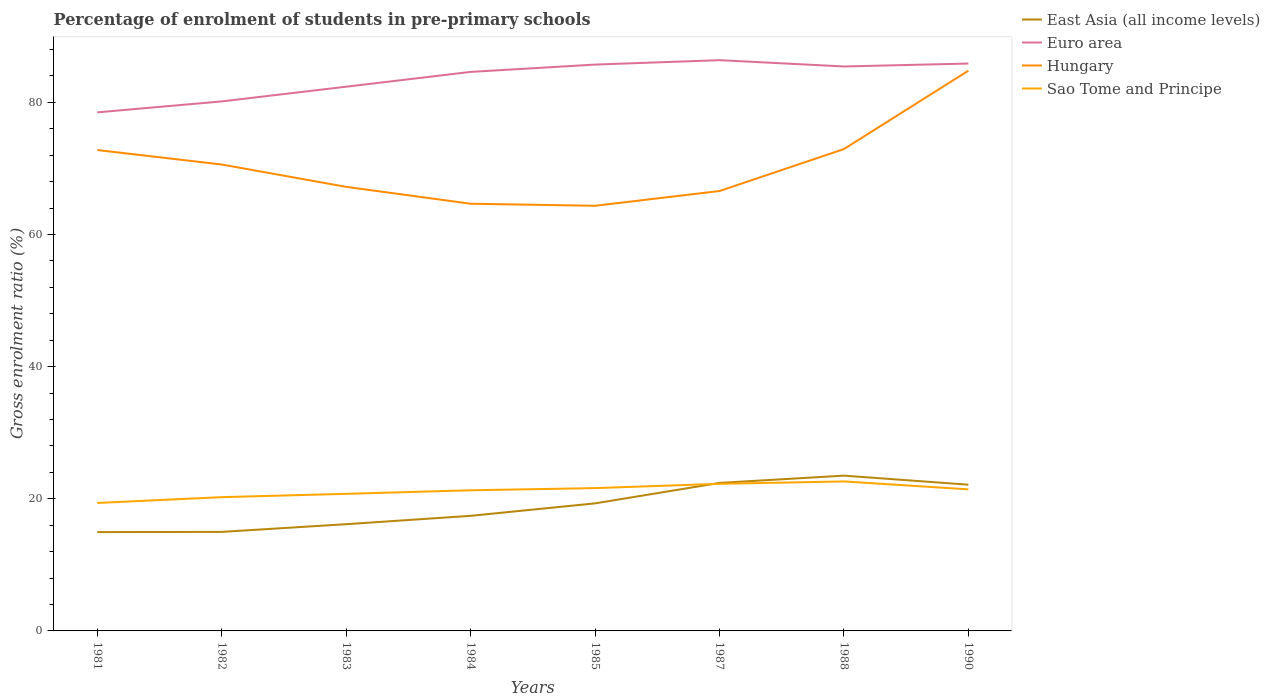Is the number of lines equal to the number of legend labels?
Provide a short and direct response. Yes. Across all years, what is the maximum percentage of students enrolled in pre-primary schools in Euro area?
Offer a terse response. 78.49. What is the total percentage of students enrolled in pre-primary schools in East Asia (all income levels) in the graph?
Offer a very short reply. -6.08. What is the difference between the highest and the second highest percentage of students enrolled in pre-primary schools in Hungary?
Your response must be concise. 20.45. What is the difference between the highest and the lowest percentage of students enrolled in pre-primary schools in Sao Tome and Principe?
Keep it short and to the point. 5. Is the percentage of students enrolled in pre-primary schools in Hungary strictly greater than the percentage of students enrolled in pre-primary schools in Euro area over the years?
Your response must be concise. Yes. How many lines are there?
Keep it short and to the point. 4. Are the values on the major ticks of Y-axis written in scientific E-notation?
Keep it short and to the point. No. Does the graph contain grids?
Your answer should be very brief. No. Where does the legend appear in the graph?
Ensure brevity in your answer.  Top right. How many legend labels are there?
Make the answer very short. 4. How are the legend labels stacked?
Your response must be concise. Vertical. What is the title of the graph?
Your response must be concise. Percentage of enrolment of students in pre-primary schools. Does "Belarus" appear as one of the legend labels in the graph?
Offer a terse response. No. What is the label or title of the Y-axis?
Ensure brevity in your answer.  Gross enrolment ratio (%). What is the Gross enrolment ratio (%) in East Asia (all income levels) in 1981?
Provide a short and direct response. 14.96. What is the Gross enrolment ratio (%) of Euro area in 1981?
Provide a short and direct response. 78.49. What is the Gross enrolment ratio (%) of Hungary in 1981?
Your response must be concise. 72.79. What is the Gross enrolment ratio (%) of Sao Tome and Principe in 1981?
Make the answer very short. 19.37. What is the Gross enrolment ratio (%) of East Asia (all income levels) in 1982?
Give a very brief answer. 14.99. What is the Gross enrolment ratio (%) in Euro area in 1982?
Your response must be concise. 80.15. What is the Gross enrolment ratio (%) of Hungary in 1982?
Offer a very short reply. 70.6. What is the Gross enrolment ratio (%) of Sao Tome and Principe in 1982?
Give a very brief answer. 20.25. What is the Gross enrolment ratio (%) of East Asia (all income levels) in 1983?
Keep it short and to the point. 16.15. What is the Gross enrolment ratio (%) in Euro area in 1983?
Ensure brevity in your answer.  82.37. What is the Gross enrolment ratio (%) of Hungary in 1983?
Ensure brevity in your answer.  67.21. What is the Gross enrolment ratio (%) of Sao Tome and Principe in 1983?
Ensure brevity in your answer.  20.75. What is the Gross enrolment ratio (%) of East Asia (all income levels) in 1984?
Your response must be concise. 17.42. What is the Gross enrolment ratio (%) of Euro area in 1984?
Provide a short and direct response. 84.61. What is the Gross enrolment ratio (%) of Hungary in 1984?
Offer a terse response. 64.66. What is the Gross enrolment ratio (%) of Sao Tome and Principe in 1984?
Give a very brief answer. 21.29. What is the Gross enrolment ratio (%) in East Asia (all income levels) in 1985?
Keep it short and to the point. 19.31. What is the Gross enrolment ratio (%) of Euro area in 1985?
Your answer should be compact. 85.72. What is the Gross enrolment ratio (%) of Hungary in 1985?
Provide a succinct answer. 64.35. What is the Gross enrolment ratio (%) in Sao Tome and Principe in 1985?
Ensure brevity in your answer.  21.62. What is the Gross enrolment ratio (%) of East Asia (all income levels) in 1987?
Keep it short and to the point. 22.4. What is the Gross enrolment ratio (%) in Euro area in 1987?
Provide a short and direct response. 86.39. What is the Gross enrolment ratio (%) in Hungary in 1987?
Your answer should be very brief. 66.58. What is the Gross enrolment ratio (%) in Sao Tome and Principe in 1987?
Offer a terse response. 22.27. What is the Gross enrolment ratio (%) in East Asia (all income levels) in 1988?
Your answer should be very brief. 23.5. What is the Gross enrolment ratio (%) in Euro area in 1988?
Offer a very short reply. 85.44. What is the Gross enrolment ratio (%) in Hungary in 1988?
Offer a terse response. 72.93. What is the Gross enrolment ratio (%) in Sao Tome and Principe in 1988?
Your response must be concise. 22.63. What is the Gross enrolment ratio (%) of East Asia (all income levels) in 1990?
Make the answer very short. 22.13. What is the Gross enrolment ratio (%) of Euro area in 1990?
Your answer should be compact. 85.88. What is the Gross enrolment ratio (%) in Hungary in 1990?
Your answer should be very brief. 84.8. What is the Gross enrolment ratio (%) in Sao Tome and Principe in 1990?
Your answer should be very brief. 21.43. Across all years, what is the maximum Gross enrolment ratio (%) of East Asia (all income levels)?
Make the answer very short. 23.5. Across all years, what is the maximum Gross enrolment ratio (%) of Euro area?
Ensure brevity in your answer.  86.39. Across all years, what is the maximum Gross enrolment ratio (%) in Hungary?
Your answer should be very brief. 84.8. Across all years, what is the maximum Gross enrolment ratio (%) in Sao Tome and Principe?
Make the answer very short. 22.63. Across all years, what is the minimum Gross enrolment ratio (%) of East Asia (all income levels)?
Make the answer very short. 14.96. Across all years, what is the minimum Gross enrolment ratio (%) in Euro area?
Offer a terse response. 78.49. Across all years, what is the minimum Gross enrolment ratio (%) in Hungary?
Your response must be concise. 64.35. Across all years, what is the minimum Gross enrolment ratio (%) in Sao Tome and Principe?
Ensure brevity in your answer.  19.37. What is the total Gross enrolment ratio (%) of East Asia (all income levels) in the graph?
Give a very brief answer. 150.87. What is the total Gross enrolment ratio (%) of Euro area in the graph?
Make the answer very short. 669.05. What is the total Gross enrolment ratio (%) in Hungary in the graph?
Your answer should be compact. 563.92. What is the total Gross enrolment ratio (%) in Sao Tome and Principe in the graph?
Your answer should be very brief. 169.59. What is the difference between the Gross enrolment ratio (%) of East Asia (all income levels) in 1981 and that in 1982?
Provide a short and direct response. -0.03. What is the difference between the Gross enrolment ratio (%) in Euro area in 1981 and that in 1982?
Give a very brief answer. -1.66. What is the difference between the Gross enrolment ratio (%) of Hungary in 1981 and that in 1982?
Provide a short and direct response. 2.19. What is the difference between the Gross enrolment ratio (%) of Sao Tome and Principe in 1981 and that in 1982?
Provide a succinct answer. -0.88. What is the difference between the Gross enrolment ratio (%) of East Asia (all income levels) in 1981 and that in 1983?
Keep it short and to the point. -1.19. What is the difference between the Gross enrolment ratio (%) of Euro area in 1981 and that in 1983?
Provide a succinct answer. -3.89. What is the difference between the Gross enrolment ratio (%) in Hungary in 1981 and that in 1983?
Offer a terse response. 5.57. What is the difference between the Gross enrolment ratio (%) of Sao Tome and Principe in 1981 and that in 1983?
Your response must be concise. -1.38. What is the difference between the Gross enrolment ratio (%) in East Asia (all income levels) in 1981 and that in 1984?
Your answer should be compact. -2.46. What is the difference between the Gross enrolment ratio (%) of Euro area in 1981 and that in 1984?
Provide a succinct answer. -6.12. What is the difference between the Gross enrolment ratio (%) in Hungary in 1981 and that in 1984?
Make the answer very short. 8.13. What is the difference between the Gross enrolment ratio (%) in Sao Tome and Principe in 1981 and that in 1984?
Give a very brief answer. -1.92. What is the difference between the Gross enrolment ratio (%) of East Asia (all income levels) in 1981 and that in 1985?
Provide a short and direct response. -4.35. What is the difference between the Gross enrolment ratio (%) in Euro area in 1981 and that in 1985?
Offer a very short reply. -7.23. What is the difference between the Gross enrolment ratio (%) in Hungary in 1981 and that in 1985?
Your answer should be very brief. 8.44. What is the difference between the Gross enrolment ratio (%) in Sao Tome and Principe in 1981 and that in 1985?
Your response must be concise. -2.25. What is the difference between the Gross enrolment ratio (%) in East Asia (all income levels) in 1981 and that in 1987?
Give a very brief answer. -7.44. What is the difference between the Gross enrolment ratio (%) in Euro area in 1981 and that in 1987?
Your answer should be very brief. -7.9. What is the difference between the Gross enrolment ratio (%) in Hungary in 1981 and that in 1987?
Offer a terse response. 6.21. What is the difference between the Gross enrolment ratio (%) of Sao Tome and Principe in 1981 and that in 1987?
Make the answer very short. -2.9. What is the difference between the Gross enrolment ratio (%) of East Asia (all income levels) in 1981 and that in 1988?
Offer a terse response. -8.55. What is the difference between the Gross enrolment ratio (%) of Euro area in 1981 and that in 1988?
Keep it short and to the point. -6.95. What is the difference between the Gross enrolment ratio (%) in Hungary in 1981 and that in 1988?
Keep it short and to the point. -0.14. What is the difference between the Gross enrolment ratio (%) of Sao Tome and Principe in 1981 and that in 1988?
Offer a terse response. -3.26. What is the difference between the Gross enrolment ratio (%) of East Asia (all income levels) in 1981 and that in 1990?
Make the answer very short. -7.17. What is the difference between the Gross enrolment ratio (%) in Euro area in 1981 and that in 1990?
Provide a short and direct response. -7.39. What is the difference between the Gross enrolment ratio (%) of Hungary in 1981 and that in 1990?
Your answer should be very brief. -12.01. What is the difference between the Gross enrolment ratio (%) of Sao Tome and Principe in 1981 and that in 1990?
Ensure brevity in your answer.  -2.06. What is the difference between the Gross enrolment ratio (%) of East Asia (all income levels) in 1982 and that in 1983?
Offer a terse response. -1.16. What is the difference between the Gross enrolment ratio (%) of Euro area in 1982 and that in 1983?
Provide a succinct answer. -2.23. What is the difference between the Gross enrolment ratio (%) in Hungary in 1982 and that in 1983?
Your response must be concise. 3.38. What is the difference between the Gross enrolment ratio (%) of Sao Tome and Principe in 1982 and that in 1983?
Your answer should be very brief. -0.5. What is the difference between the Gross enrolment ratio (%) of East Asia (all income levels) in 1982 and that in 1984?
Ensure brevity in your answer.  -2.43. What is the difference between the Gross enrolment ratio (%) in Euro area in 1982 and that in 1984?
Provide a succinct answer. -4.47. What is the difference between the Gross enrolment ratio (%) in Hungary in 1982 and that in 1984?
Your answer should be compact. 5.94. What is the difference between the Gross enrolment ratio (%) in Sao Tome and Principe in 1982 and that in 1984?
Your response must be concise. -1.04. What is the difference between the Gross enrolment ratio (%) in East Asia (all income levels) in 1982 and that in 1985?
Offer a terse response. -4.32. What is the difference between the Gross enrolment ratio (%) of Euro area in 1982 and that in 1985?
Offer a terse response. -5.58. What is the difference between the Gross enrolment ratio (%) in Hungary in 1982 and that in 1985?
Keep it short and to the point. 6.25. What is the difference between the Gross enrolment ratio (%) in Sao Tome and Principe in 1982 and that in 1985?
Your response must be concise. -1.37. What is the difference between the Gross enrolment ratio (%) in East Asia (all income levels) in 1982 and that in 1987?
Your answer should be compact. -7.41. What is the difference between the Gross enrolment ratio (%) of Euro area in 1982 and that in 1987?
Provide a succinct answer. -6.24. What is the difference between the Gross enrolment ratio (%) of Hungary in 1982 and that in 1987?
Provide a succinct answer. 4.01. What is the difference between the Gross enrolment ratio (%) in Sao Tome and Principe in 1982 and that in 1987?
Your answer should be compact. -2.02. What is the difference between the Gross enrolment ratio (%) in East Asia (all income levels) in 1982 and that in 1988?
Offer a very short reply. -8.51. What is the difference between the Gross enrolment ratio (%) in Euro area in 1982 and that in 1988?
Make the answer very short. -5.29. What is the difference between the Gross enrolment ratio (%) in Hungary in 1982 and that in 1988?
Offer a very short reply. -2.34. What is the difference between the Gross enrolment ratio (%) in Sao Tome and Principe in 1982 and that in 1988?
Ensure brevity in your answer.  -2.38. What is the difference between the Gross enrolment ratio (%) in East Asia (all income levels) in 1982 and that in 1990?
Your response must be concise. -7.14. What is the difference between the Gross enrolment ratio (%) in Euro area in 1982 and that in 1990?
Provide a short and direct response. -5.73. What is the difference between the Gross enrolment ratio (%) of Hungary in 1982 and that in 1990?
Make the answer very short. -14.2. What is the difference between the Gross enrolment ratio (%) in Sao Tome and Principe in 1982 and that in 1990?
Offer a very short reply. -1.18. What is the difference between the Gross enrolment ratio (%) in East Asia (all income levels) in 1983 and that in 1984?
Provide a short and direct response. -1.27. What is the difference between the Gross enrolment ratio (%) of Euro area in 1983 and that in 1984?
Give a very brief answer. -2.24. What is the difference between the Gross enrolment ratio (%) of Hungary in 1983 and that in 1984?
Provide a succinct answer. 2.55. What is the difference between the Gross enrolment ratio (%) in Sao Tome and Principe in 1983 and that in 1984?
Keep it short and to the point. -0.54. What is the difference between the Gross enrolment ratio (%) of East Asia (all income levels) in 1983 and that in 1985?
Provide a succinct answer. -3.15. What is the difference between the Gross enrolment ratio (%) of Euro area in 1983 and that in 1985?
Your answer should be very brief. -3.35. What is the difference between the Gross enrolment ratio (%) of Hungary in 1983 and that in 1985?
Offer a very short reply. 2.86. What is the difference between the Gross enrolment ratio (%) in Sao Tome and Principe in 1983 and that in 1985?
Ensure brevity in your answer.  -0.87. What is the difference between the Gross enrolment ratio (%) of East Asia (all income levels) in 1983 and that in 1987?
Give a very brief answer. -6.25. What is the difference between the Gross enrolment ratio (%) of Euro area in 1983 and that in 1987?
Offer a terse response. -4.02. What is the difference between the Gross enrolment ratio (%) in Hungary in 1983 and that in 1987?
Keep it short and to the point. 0.63. What is the difference between the Gross enrolment ratio (%) in Sao Tome and Principe in 1983 and that in 1987?
Provide a short and direct response. -1.52. What is the difference between the Gross enrolment ratio (%) of East Asia (all income levels) in 1983 and that in 1988?
Make the answer very short. -7.35. What is the difference between the Gross enrolment ratio (%) of Euro area in 1983 and that in 1988?
Your response must be concise. -3.06. What is the difference between the Gross enrolment ratio (%) of Hungary in 1983 and that in 1988?
Your response must be concise. -5.72. What is the difference between the Gross enrolment ratio (%) of Sao Tome and Principe in 1983 and that in 1988?
Give a very brief answer. -1.88. What is the difference between the Gross enrolment ratio (%) of East Asia (all income levels) in 1983 and that in 1990?
Your answer should be compact. -5.98. What is the difference between the Gross enrolment ratio (%) in Euro area in 1983 and that in 1990?
Give a very brief answer. -3.5. What is the difference between the Gross enrolment ratio (%) of Hungary in 1983 and that in 1990?
Your answer should be compact. -17.58. What is the difference between the Gross enrolment ratio (%) in Sao Tome and Principe in 1983 and that in 1990?
Your answer should be compact. -0.68. What is the difference between the Gross enrolment ratio (%) in East Asia (all income levels) in 1984 and that in 1985?
Ensure brevity in your answer.  -1.89. What is the difference between the Gross enrolment ratio (%) in Euro area in 1984 and that in 1985?
Your response must be concise. -1.11. What is the difference between the Gross enrolment ratio (%) of Hungary in 1984 and that in 1985?
Offer a terse response. 0.31. What is the difference between the Gross enrolment ratio (%) in Sao Tome and Principe in 1984 and that in 1985?
Make the answer very short. -0.33. What is the difference between the Gross enrolment ratio (%) in East Asia (all income levels) in 1984 and that in 1987?
Ensure brevity in your answer.  -4.98. What is the difference between the Gross enrolment ratio (%) in Euro area in 1984 and that in 1987?
Keep it short and to the point. -1.78. What is the difference between the Gross enrolment ratio (%) in Hungary in 1984 and that in 1987?
Your answer should be very brief. -1.92. What is the difference between the Gross enrolment ratio (%) of Sao Tome and Principe in 1984 and that in 1987?
Give a very brief answer. -0.98. What is the difference between the Gross enrolment ratio (%) in East Asia (all income levels) in 1984 and that in 1988?
Offer a very short reply. -6.08. What is the difference between the Gross enrolment ratio (%) in Euro area in 1984 and that in 1988?
Offer a terse response. -0.82. What is the difference between the Gross enrolment ratio (%) in Hungary in 1984 and that in 1988?
Offer a terse response. -8.27. What is the difference between the Gross enrolment ratio (%) of Sao Tome and Principe in 1984 and that in 1988?
Offer a very short reply. -1.34. What is the difference between the Gross enrolment ratio (%) of East Asia (all income levels) in 1984 and that in 1990?
Make the answer very short. -4.71. What is the difference between the Gross enrolment ratio (%) in Euro area in 1984 and that in 1990?
Make the answer very short. -1.27. What is the difference between the Gross enrolment ratio (%) of Hungary in 1984 and that in 1990?
Offer a very short reply. -20.14. What is the difference between the Gross enrolment ratio (%) of Sao Tome and Principe in 1984 and that in 1990?
Your response must be concise. -0.14. What is the difference between the Gross enrolment ratio (%) of East Asia (all income levels) in 1985 and that in 1987?
Make the answer very short. -3.1. What is the difference between the Gross enrolment ratio (%) in Euro area in 1985 and that in 1987?
Make the answer very short. -0.67. What is the difference between the Gross enrolment ratio (%) of Hungary in 1985 and that in 1987?
Keep it short and to the point. -2.23. What is the difference between the Gross enrolment ratio (%) of Sao Tome and Principe in 1985 and that in 1987?
Provide a short and direct response. -0.65. What is the difference between the Gross enrolment ratio (%) of East Asia (all income levels) in 1985 and that in 1988?
Provide a short and direct response. -4.2. What is the difference between the Gross enrolment ratio (%) of Euro area in 1985 and that in 1988?
Make the answer very short. 0.29. What is the difference between the Gross enrolment ratio (%) in Hungary in 1985 and that in 1988?
Your response must be concise. -8.58. What is the difference between the Gross enrolment ratio (%) of Sao Tome and Principe in 1985 and that in 1988?
Offer a terse response. -1.01. What is the difference between the Gross enrolment ratio (%) of East Asia (all income levels) in 1985 and that in 1990?
Offer a terse response. -2.83. What is the difference between the Gross enrolment ratio (%) of Euro area in 1985 and that in 1990?
Give a very brief answer. -0.16. What is the difference between the Gross enrolment ratio (%) in Hungary in 1985 and that in 1990?
Your answer should be very brief. -20.45. What is the difference between the Gross enrolment ratio (%) in Sao Tome and Principe in 1985 and that in 1990?
Keep it short and to the point. 0.19. What is the difference between the Gross enrolment ratio (%) in East Asia (all income levels) in 1987 and that in 1988?
Your answer should be very brief. -1.1. What is the difference between the Gross enrolment ratio (%) of Euro area in 1987 and that in 1988?
Give a very brief answer. 0.95. What is the difference between the Gross enrolment ratio (%) of Hungary in 1987 and that in 1988?
Your answer should be compact. -6.35. What is the difference between the Gross enrolment ratio (%) of Sao Tome and Principe in 1987 and that in 1988?
Your answer should be very brief. -0.36. What is the difference between the Gross enrolment ratio (%) of East Asia (all income levels) in 1987 and that in 1990?
Your answer should be compact. 0.27. What is the difference between the Gross enrolment ratio (%) of Euro area in 1987 and that in 1990?
Your response must be concise. 0.51. What is the difference between the Gross enrolment ratio (%) of Hungary in 1987 and that in 1990?
Provide a succinct answer. -18.22. What is the difference between the Gross enrolment ratio (%) in Sao Tome and Principe in 1987 and that in 1990?
Your response must be concise. 0.84. What is the difference between the Gross enrolment ratio (%) of East Asia (all income levels) in 1988 and that in 1990?
Make the answer very short. 1.37. What is the difference between the Gross enrolment ratio (%) of Euro area in 1988 and that in 1990?
Make the answer very short. -0.44. What is the difference between the Gross enrolment ratio (%) in Hungary in 1988 and that in 1990?
Make the answer very short. -11.87. What is the difference between the Gross enrolment ratio (%) of Sao Tome and Principe in 1988 and that in 1990?
Provide a short and direct response. 1.2. What is the difference between the Gross enrolment ratio (%) of East Asia (all income levels) in 1981 and the Gross enrolment ratio (%) of Euro area in 1982?
Provide a short and direct response. -65.19. What is the difference between the Gross enrolment ratio (%) in East Asia (all income levels) in 1981 and the Gross enrolment ratio (%) in Hungary in 1982?
Provide a succinct answer. -55.64. What is the difference between the Gross enrolment ratio (%) of East Asia (all income levels) in 1981 and the Gross enrolment ratio (%) of Sao Tome and Principe in 1982?
Provide a short and direct response. -5.29. What is the difference between the Gross enrolment ratio (%) of Euro area in 1981 and the Gross enrolment ratio (%) of Hungary in 1982?
Provide a short and direct response. 7.89. What is the difference between the Gross enrolment ratio (%) in Euro area in 1981 and the Gross enrolment ratio (%) in Sao Tome and Principe in 1982?
Give a very brief answer. 58.24. What is the difference between the Gross enrolment ratio (%) in Hungary in 1981 and the Gross enrolment ratio (%) in Sao Tome and Principe in 1982?
Your answer should be compact. 52.54. What is the difference between the Gross enrolment ratio (%) of East Asia (all income levels) in 1981 and the Gross enrolment ratio (%) of Euro area in 1983?
Keep it short and to the point. -67.42. What is the difference between the Gross enrolment ratio (%) of East Asia (all income levels) in 1981 and the Gross enrolment ratio (%) of Hungary in 1983?
Your answer should be compact. -52.26. What is the difference between the Gross enrolment ratio (%) in East Asia (all income levels) in 1981 and the Gross enrolment ratio (%) in Sao Tome and Principe in 1983?
Offer a very short reply. -5.79. What is the difference between the Gross enrolment ratio (%) of Euro area in 1981 and the Gross enrolment ratio (%) of Hungary in 1983?
Offer a very short reply. 11.27. What is the difference between the Gross enrolment ratio (%) in Euro area in 1981 and the Gross enrolment ratio (%) in Sao Tome and Principe in 1983?
Provide a short and direct response. 57.74. What is the difference between the Gross enrolment ratio (%) of Hungary in 1981 and the Gross enrolment ratio (%) of Sao Tome and Principe in 1983?
Provide a succinct answer. 52.04. What is the difference between the Gross enrolment ratio (%) of East Asia (all income levels) in 1981 and the Gross enrolment ratio (%) of Euro area in 1984?
Give a very brief answer. -69.65. What is the difference between the Gross enrolment ratio (%) of East Asia (all income levels) in 1981 and the Gross enrolment ratio (%) of Hungary in 1984?
Your response must be concise. -49.7. What is the difference between the Gross enrolment ratio (%) in East Asia (all income levels) in 1981 and the Gross enrolment ratio (%) in Sao Tome and Principe in 1984?
Offer a terse response. -6.33. What is the difference between the Gross enrolment ratio (%) of Euro area in 1981 and the Gross enrolment ratio (%) of Hungary in 1984?
Give a very brief answer. 13.83. What is the difference between the Gross enrolment ratio (%) of Euro area in 1981 and the Gross enrolment ratio (%) of Sao Tome and Principe in 1984?
Keep it short and to the point. 57.2. What is the difference between the Gross enrolment ratio (%) in Hungary in 1981 and the Gross enrolment ratio (%) in Sao Tome and Principe in 1984?
Offer a terse response. 51.5. What is the difference between the Gross enrolment ratio (%) in East Asia (all income levels) in 1981 and the Gross enrolment ratio (%) in Euro area in 1985?
Your answer should be very brief. -70.76. What is the difference between the Gross enrolment ratio (%) in East Asia (all income levels) in 1981 and the Gross enrolment ratio (%) in Hungary in 1985?
Provide a short and direct response. -49.39. What is the difference between the Gross enrolment ratio (%) in East Asia (all income levels) in 1981 and the Gross enrolment ratio (%) in Sao Tome and Principe in 1985?
Make the answer very short. -6.66. What is the difference between the Gross enrolment ratio (%) in Euro area in 1981 and the Gross enrolment ratio (%) in Hungary in 1985?
Your answer should be very brief. 14.14. What is the difference between the Gross enrolment ratio (%) of Euro area in 1981 and the Gross enrolment ratio (%) of Sao Tome and Principe in 1985?
Provide a succinct answer. 56.87. What is the difference between the Gross enrolment ratio (%) in Hungary in 1981 and the Gross enrolment ratio (%) in Sao Tome and Principe in 1985?
Make the answer very short. 51.17. What is the difference between the Gross enrolment ratio (%) of East Asia (all income levels) in 1981 and the Gross enrolment ratio (%) of Euro area in 1987?
Your answer should be very brief. -71.43. What is the difference between the Gross enrolment ratio (%) of East Asia (all income levels) in 1981 and the Gross enrolment ratio (%) of Hungary in 1987?
Provide a short and direct response. -51.62. What is the difference between the Gross enrolment ratio (%) of East Asia (all income levels) in 1981 and the Gross enrolment ratio (%) of Sao Tome and Principe in 1987?
Your answer should be very brief. -7.31. What is the difference between the Gross enrolment ratio (%) in Euro area in 1981 and the Gross enrolment ratio (%) in Hungary in 1987?
Keep it short and to the point. 11.91. What is the difference between the Gross enrolment ratio (%) of Euro area in 1981 and the Gross enrolment ratio (%) of Sao Tome and Principe in 1987?
Offer a terse response. 56.22. What is the difference between the Gross enrolment ratio (%) of Hungary in 1981 and the Gross enrolment ratio (%) of Sao Tome and Principe in 1987?
Your answer should be compact. 50.52. What is the difference between the Gross enrolment ratio (%) in East Asia (all income levels) in 1981 and the Gross enrolment ratio (%) in Euro area in 1988?
Make the answer very short. -70.48. What is the difference between the Gross enrolment ratio (%) of East Asia (all income levels) in 1981 and the Gross enrolment ratio (%) of Hungary in 1988?
Your answer should be compact. -57.97. What is the difference between the Gross enrolment ratio (%) of East Asia (all income levels) in 1981 and the Gross enrolment ratio (%) of Sao Tome and Principe in 1988?
Provide a short and direct response. -7.67. What is the difference between the Gross enrolment ratio (%) of Euro area in 1981 and the Gross enrolment ratio (%) of Hungary in 1988?
Your response must be concise. 5.56. What is the difference between the Gross enrolment ratio (%) of Euro area in 1981 and the Gross enrolment ratio (%) of Sao Tome and Principe in 1988?
Give a very brief answer. 55.86. What is the difference between the Gross enrolment ratio (%) in Hungary in 1981 and the Gross enrolment ratio (%) in Sao Tome and Principe in 1988?
Offer a terse response. 50.16. What is the difference between the Gross enrolment ratio (%) in East Asia (all income levels) in 1981 and the Gross enrolment ratio (%) in Euro area in 1990?
Ensure brevity in your answer.  -70.92. What is the difference between the Gross enrolment ratio (%) in East Asia (all income levels) in 1981 and the Gross enrolment ratio (%) in Hungary in 1990?
Provide a short and direct response. -69.84. What is the difference between the Gross enrolment ratio (%) in East Asia (all income levels) in 1981 and the Gross enrolment ratio (%) in Sao Tome and Principe in 1990?
Ensure brevity in your answer.  -6.47. What is the difference between the Gross enrolment ratio (%) of Euro area in 1981 and the Gross enrolment ratio (%) of Hungary in 1990?
Ensure brevity in your answer.  -6.31. What is the difference between the Gross enrolment ratio (%) in Euro area in 1981 and the Gross enrolment ratio (%) in Sao Tome and Principe in 1990?
Provide a succinct answer. 57.06. What is the difference between the Gross enrolment ratio (%) of Hungary in 1981 and the Gross enrolment ratio (%) of Sao Tome and Principe in 1990?
Your answer should be compact. 51.36. What is the difference between the Gross enrolment ratio (%) in East Asia (all income levels) in 1982 and the Gross enrolment ratio (%) in Euro area in 1983?
Keep it short and to the point. -67.38. What is the difference between the Gross enrolment ratio (%) in East Asia (all income levels) in 1982 and the Gross enrolment ratio (%) in Hungary in 1983?
Keep it short and to the point. -52.22. What is the difference between the Gross enrolment ratio (%) in East Asia (all income levels) in 1982 and the Gross enrolment ratio (%) in Sao Tome and Principe in 1983?
Your answer should be compact. -5.76. What is the difference between the Gross enrolment ratio (%) in Euro area in 1982 and the Gross enrolment ratio (%) in Hungary in 1983?
Provide a succinct answer. 12.93. What is the difference between the Gross enrolment ratio (%) in Euro area in 1982 and the Gross enrolment ratio (%) in Sao Tome and Principe in 1983?
Your answer should be very brief. 59.4. What is the difference between the Gross enrolment ratio (%) in Hungary in 1982 and the Gross enrolment ratio (%) in Sao Tome and Principe in 1983?
Offer a terse response. 49.85. What is the difference between the Gross enrolment ratio (%) of East Asia (all income levels) in 1982 and the Gross enrolment ratio (%) of Euro area in 1984?
Your answer should be very brief. -69.62. What is the difference between the Gross enrolment ratio (%) in East Asia (all income levels) in 1982 and the Gross enrolment ratio (%) in Hungary in 1984?
Offer a terse response. -49.67. What is the difference between the Gross enrolment ratio (%) of East Asia (all income levels) in 1982 and the Gross enrolment ratio (%) of Sao Tome and Principe in 1984?
Your response must be concise. -6.3. What is the difference between the Gross enrolment ratio (%) in Euro area in 1982 and the Gross enrolment ratio (%) in Hungary in 1984?
Provide a succinct answer. 15.49. What is the difference between the Gross enrolment ratio (%) of Euro area in 1982 and the Gross enrolment ratio (%) of Sao Tome and Principe in 1984?
Your response must be concise. 58.86. What is the difference between the Gross enrolment ratio (%) of Hungary in 1982 and the Gross enrolment ratio (%) of Sao Tome and Principe in 1984?
Your answer should be very brief. 49.31. What is the difference between the Gross enrolment ratio (%) in East Asia (all income levels) in 1982 and the Gross enrolment ratio (%) in Euro area in 1985?
Your answer should be very brief. -70.73. What is the difference between the Gross enrolment ratio (%) of East Asia (all income levels) in 1982 and the Gross enrolment ratio (%) of Hungary in 1985?
Provide a short and direct response. -49.36. What is the difference between the Gross enrolment ratio (%) in East Asia (all income levels) in 1982 and the Gross enrolment ratio (%) in Sao Tome and Principe in 1985?
Make the answer very short. -6.63. What is the difference between the Gross enrolment ratio (%) of Euro area in 1982 and the Gross enrolment ratio (%) of Hungary in 1985?
Offer a very short reply. 15.8. What is the difference between the Gross enrolment ratio (%) in Euro area in 1982 and the Gross enrolment ratio (%) in Sao Tome and Principe in 1985?
Ensure brevity in your answer.  58.53. What is the difference between the Gross enrolment ratio (%) in Hungary in 1982 and the Gross enrolment ratio (%) in Sao Tome and Principe in 1985?
Offer a terse response. 48.98. What is the difference between the Gross enrolment ratio (%) in East Asia (all income levels) in 1982 and the Gross enrolment ratio (%) in Euro area in 1987?
Your answer should be very brief. -71.4. What is the difference between the Gross enrolment ratio (%) in East Asia (all income levels) in 1982 and the Gross enrolment ratio (%) in Hungary in 1987?
Your response must be concise. -51.59. What is the difference between the Gross enrolment ratio (%) of East Asia (all income levels) in 1982 and the Gross enrolment ratio (%) of Sao Tome and Principe in 1987?
Your response must be concise. -7.28. What is the difference between the Gross enrolment ratio (%) of Euro area in 1982 and the Gross enrolment ratio (%) of Hungary in 1987?
Provide a succinct answer. 13.56. What is the difference between the Gross enrolment ratio (%) in Euro area in 1982 and the Gross enrolment ratio (%) in Sao Tome and Principe in 1987?
Provide a succinct answer. 57.88. What is the difference between the Gross enrolment ratio (%) of Hungary in 1982 and the Gross enrolment ratio (%) of Sao Tome and Principe in 1987?
Ensure brevity in your answer.  48.33. What is the difference between the Gross enrolment ratio (%) of East Asia (all income levels) in 1982 and the Gross enrolment ratio (%) of Euro area in 1988?
Make the answer very short. -70.45. What is the difference between the Gross enrolment ratio (%) in East Asia (all income levels) in 1982 and the Gross enrolment ratio (%) in Hungary in 1988?
Ensure brevity in your answer.  -57.94. What is the difference between the Gross enrolment ratio (%) of East Asia (all income levels) in 1982 and the Gross enrolment ratio (%) of Sao Tome and Principe in 1988?
Offer a terse response. -7.64. What is the difference between the Gross enrolment ratio (%) of Euro area in 1982 and the Gross enrolment ratio (%) of Hungary in 1988?
Your answer should be compact. 7.21. What is the difference between the Gross enrolment ratio (%) of Euro area in 1982 and the Gross enrolment ratio (%) of Sao Tome and Principe in 1988?
Offer a very short reply. 57.52. What is the difference between the Gross enrolment ratio (%) in Hungary in 1982 and the Gross enrolment ratio (%) in Sao Tome and Principe in 1988?
Offer a terse response. 47.97. What is the difference between the Gross enrolment ratio (%) of East Asia (all income levels) in 1982 and the Gross enrolment ratio (%) of Euro area in 1990?
Offer a terse response. -70.89. What is the difference between the Gross enrolment ratio (%) in East Asia (all income levels) in 1982 and the Gross enrolment ratio (%) in Hungary in 1990?
Your response must be concise. -69.81. What is the difference between the Gross enrolment ratio (%) of East Asia (all income levels) in 1982 and the Gross enrolment ratio (%) of Sao Tome and Principe in 1990?
Your answer should be compact. -6.44. What is the difference between the Gross enrolment ratio (%) in Euro area in 1982 and the Gross enrolment ratio (%) in Hungary in 1990?
Offer a terse response. -4.65. What is the difference between the Gross enrolment ratio (%) of Euro area in 1982 and the Gross enrolment ratio (%) of Sao Tome and Principe in 1990?
Offer a terse response. 58.72. What is the difference between the Gross enrolment ratio (%) of Hungary in 1982 and the Gross enrolment ratio (%) of Sao Tome and Principe in 1990?
Your answer should be compact. 49.17. What is the difference between the Gross enrolment ratio (%) of East Asia (all income levels) in 1983 and the Gross enrolment ratio (%) of Euro area in 1984?
Provide a succinct answer. -68.46. What is the difference between the Gross enrolment ratio (%) of East Asia (all income levels) in 1983 and the Gross enrolment ratio (%) of Hungary in 1984?
Your answer should be compact. -48.51. What is the difference between the Gross enrolment ratio (%) in East Asia (all income levels) in 1983 and the Gross enrolment ratio (%) in Sao Tome and Principe in 1984?
Your response must be concise. -5.13. What is the difference between the Gross enrolment ratio (%) of Euro area in 1983 and the Gross enrolment ratio (%) of Hungary in 1984?
Make the answer very short. 17.71. What is the difference between the Gross enrolment ratio (%) in Euro area in 1983 and the Gross enrolment ratio (%) in Sao Tome and Principe in 1984?
Provide a succinct answer. 61.09. What is the difference between the Gross enrolment ratio (%) in Hungary in 1983 and the Gross enrolment ratio (%) in Sao Tome and Principe in 1984?
Provide a succinct answer. 45.93. What is the difference between the Gross enrolment ratio (%) in East Asia (all income levels) in 1983 and the Gross enrolment ratio (%) in Euro area in 1985?
Make the answer very short. -69.57. What is the difference between the Gross enrolment ratio (%) in East Asia (all income levels) in 1983 and the Gross enrolment ratio (%) in Hungary in 1985?
Offer a terse response. -48.2. What is the difference between the Gross enrolment ratio (%) in East Asia (all income levels) in 1983 and the Gross enrolment ratio (%) in Sao Tome and Principe in 1985?
Offer a very short reply. -5.46. What is the difference between the Gross enrolment ratio (%) of Euro area in 1983 and the Gross enrolment ratio (%) of Hungary in 1985?
Keep it short and to the point. 18.02. What is the difference between the Gross enrolment ratio (%) of Euro area in 1983 and the Gross enrolment ratio (%) of Sao Tome and Principe in 1985?
Keep it short and to the point. 60.76. What is the difference between the Gross enrolment ratio (%) of Hungary in 1983 and the Gross enrolment ratio (%) of Sao Tome and Principe in 1985?
Give a very brief answer. 45.6. What is the difference between the Gross enrolment ratio (%) in East Asia (all income levels) in 1983 and the Gross enrolment ratio (%) in Euro area in 1987?
Offer a very short reply. -70.24. What is the difference between the Gross enrolment ratio (%) of East Asia (all income levels) in 1983 and the Gross enrolment ratio (%) of Hungary in 1987?
Keep it short and to the point. -50.43. What is the difference between the Gross enrolment ratio (%) in East Asia (all income levels) in 1983 and the Gross enrolment ratio (%) in Sao Tome and Principe in 1987?
Your response must be concise. -6.11. What is the difference between the Gross enrolment ratio (%) in Euro area in 1983 and the Gross enrolment ratio (%) in Hungary in 1987?
Ensure brevity in your answer.  15.79. What is the difference between the Gross enrolment ratio (%) in Euro area in 1983 and the Gross enrolment ratio (%) in Sao Tome and Principe in 1987?
Your answer should be compact. 60.11. What is the difference between the Gross enrolment ratio (%) of Hungary in 1983 and the Gross enrolment ratio (%) of Sao Tome and Principe in 1987?
Offer a terse response. 44.95. What is the difference between the Gross enrolment ratio (%) of East Asia (all income levels) in 1983 and the Gross enrolment ratio (%) of Euro area in 1988?
Make the answer very short. -69.28. What is the difference between the Gross enrolment ratio (%) in East Asia (all income levels) in 1983 and the Gross enrolment ratio (%) in Hungary in 1988?
Your answer should be very brief. -56.78. What is the difference between the Gross enrolment ratio (%) of East Asia (all income levels) in 1983 and the Gross enrolment ratio (%) of Sao Tome and Principe in 1988?
Provide a succinct answer. -6.47. What is the difference between the Gross enrolment ratio (%) in Euro area in 1983 and the Gross enrolment ratio (%) in Hungary in 1988?
Offer a very short reply. 9.44. What is the difference between the Gross enrolment ratio (%) in Euro area in 1983 and the Gross enrolment ratio (%) in Sao Tome and Principe in 1988?
Offer a terse response. 59.75. What is the difference between the Gross enrolment ratio (%) in Hungary in 1983 and the Gross enrolment ratio (%) in Sao Tome and Principe in 1988?
Your response must be concise. 44.59. What is the difference between the Gross enrolment ratio (%) in East Asia (all income levels) in 1983 and the Gross enrolment ratio (%) in Euro area in 1990?
Offer a very short reply. -69.73. What is the difference between the Gross enrolment ratio (%) in East Asia (all income levels) in 1983 and the Gross enrolment ratio (%) in Hungary in 1990?
Give a very brief answer. -68.65. What is the difference between the Gross enrolment ratio (%) of East Asia (all income levels) in 1983 and the Gross enrolment ratio (%) of Sao Tome and Principe in 1990?
Make the answer very short. -5.28. What is the difference between the Gross enrolment ratio (%) in Euro area in 1983 and the Gross enrolment ratio (%) in Hungary in 1990?
Keep it short and to the point. -2.42. What is the difference between the Gross enrolment ratio (%) of Euro area in 1983 and the Gross enrolment ratio (%) of Sao Tome and Principe in 1990?
Your response must be concise. 60.95. What is the difference between the Gross enrolment ratio (%) in Hungary in 1983 and the Gross enrolment ratio (%) in Sao Tome and Principe in 1990?
Offer a terse response. 45.78. What is the difference between the Gross enrolment ratio (%) in East Asia (all income levels) in 1984 and the Gross enrolment ratio (%) in Euro area in 1985?
Provide a short and direct response. -68.3. What is the difference between the Gross enrolment ratio (%) of East Asia (all income levels) in 1984 and the Gross enrolment ratio (%) of Hungary in 1985?
Keep it short and to the point. -46.93. What is the difference between the Gross enrolment ratio (%) of East Asia (all income levels) in 1984 and the Gross enrolment ratio (%) of Sao Tome and Principe in 1985?
Your answer should be compact. -4.2. What is the difference between the Gross enrolment ratio (%) of Euro area in 1984 and the Gross enrolment ratio (%) of Hungary in 1985?
Make the answer very short. 20.26. What is the difference between the Gross enrolment ratio (%) in Euro area in 1984 and the Gross enrolment ratio (%) in Sao Tome and Principe in 1985?
Give a very brief answer. 63. What is the difference between the Gross enrolment ratio (%) of Hungary in 1984 and the Gross enrolment ratio (%) of Sao Tome and Principe in 1985?
Your answer should be compact. 43.04. What is the difference between the Gross enrolment ratio (%) in East Asia (all income levels) in 1984 and the Gross enrolment ratio (%) in Euro area in 1987?
Give a very brief answer. -68.97. What is the difference between the Gross enrolment ratio (%) in East Asia (all income levels) in 1984 and the Gross enrolment ratio (%) in Hungary in 1987?
Give a very brief answer. -49.16. What is the difference between the Gross enrolment ratio (%) of East Asia (all income levels) in 1984 and the Gross enrolment ratio (%) of Sao Tome and Principe in 1987?
Offer a terse response. -4.85. What is the difference between the Gross enrolment ratio (%) in Euro area in 1984 and the Gross enrolment ratio (%) in Hungary in 1987?
Make the answer very short. 18.03. What is the difference between the Gross enrolment ratio (%) in Euro area in 1984 and the Gross enrolment ratio (%) in Sao Tome and Principe in 1987?
Keep it short and to the point. 62.35. What is the difference between the Gross enrolment ratio (%) of Hungary in 1984 and the Gross enrolment ratio (%) of Sao Tome and Principe in 1987?
Your response must be concise. 42.39. What is the difference between the Gross enrolment ratio (%) in East Asia (all income levels) in 1984 and the Gross enrolment ratio (%) in Euro area in 1988?
Your answer should be compact. -68.02. What is the difference between the Gross enrolment ratio (%) in East Asia (all income levels) in 1984 and the Gross enrolment ratio (%) in Hungary in 1988?
Offer a very short reply. -55.51. What is the difference between the Gross enrolment ratio (%) in East Asia (all income levels) in 1984 and the Gross enrolment ratio (%) in Sao Tome and Principe in 1988?
Give a very brief answer. -5.21. What is the difference between the Gross enrolment ratio (%) of Euro area in 1984 and the Gross enrolment ratio (%) of Hungary in 1988?
Ensure brevity in your answer.  11.68. What is the difference between the Gross enrolment ratio (%) in Euro area in 1984 and the Gross enrolment ratio (%) in Sao Tome and Principe in 1988?
Give a very brief answer. 61.99. What is the difference between the Gross enrolment ratio (%) in Hungary in 1984 and the Gross enrolment ratio (%) in Sao Tome and Principe in 1988?
Offer a very short reply. 42.03. What is the difference between the Gross enrolment ratio (%) in East Asia (all income levels) in 1984 and the Gross enrolment ratio (%) in Euro area in 1990?
Make the answer very short. -68.46. What is the difference between the Gross enrolment ratio (%) in East Asia (all income levels) in 1984 and the Gross enrolment ratio (%) in Hungary in 1990?
Your answer should be compact. -67.38. What is the difference between the Gross enrolment ratio (%) of East Asia (all income levels) in 1984 and the Gross enrolment ratio (%) of Sao Tome and Principe in 1990?
Make the answer very short. -4.01. What is the difference between the Gross enrolment ratio (%) of Euro area in 1984 and the Gross enrolment ratio (%) of Hungary in 1990?
Offer a terse response. -0.18. What is the difference between the Gross enrolment ratio (%) in Euro area in 1984 and the Gross enrolment ratio (%) in Sao Tome and Principe in 1990?
Your answer should be very brief. 63.18. What is the difference between the Gross enrolment ratio (%) of Hungary in 1984 and the Gross enrolment ratio (%) of Sao Tome and Principe in 1990?
Your response must be concise. 43.23. What is the difference between the Gross enrolment ratio (%) in East Asia (all income levels) in 1985 and the Gross enrolment ratio (%) in Euro area in 1987?
Offer a terse response. -67.08. What is the difference between the Gross enrolment ratio (%) in East Asia (all income levels) in 1985 and the Gross enrolment ratio (%) in Hungary in 1987?
Your response must be concise. -47.28. What is the difference between the Gross enrolment ratio (%) in East Asia (all income levels) in 1985 and the Gross enrolment ratio (%) in Sao Tome and Principe in 1987?
Ensure brevity in your answer.  -2.96. What is the difference between the Gross enrolment ratio (%) of Euro area in 1985 and the Gross enrolment ratio (%) of Hungary in 1987?
Your response must be concise. 19.14. What is the difference between the Gross enrolment ratio (%) in Euro area in 1985 and the Gross enrolment ratio (%) in Sao Tome and Principe in 1987?
Offer a very short reply. 63.46. What is the difference between the Gross enrolment ratio (%) in Hungary in 1985 and the Gross enrolment ratio (%) in Sao Tome and Principe in 1987?
Offer a terse response. 42.08. What is the difference between the Gross enrolment ratio (%) in East Asia (all income levels) in 1985 and the Gross enrolment ratio (%) in Euro area in 1988?
Ensure brevity in your answer.  -66.13. What is the difference between the Gross enrolment ratio (%) of East Asia (all income levels) in 1985 and the Gross enrolment ratio (%) of Hungary in 1988?
Make the answer very short. -53.63. What is the difference between the Gross enrolment ratio (%) of East Asia (all income levels) in 1985 and the Gross enrolment ratio (%) of Sao Tome and Principe in 1988?
Offer a very short reply. -3.32. What is the difference between the Gross enrolment ratio (%) of Euro area in 1985 and the Gross enrolment ratio (%) of Hungary in 1988?
Ensure brevity in your answer.  12.79. What is the difference between the Gross enrolment ratio (%) of Euro area in 1985 and the Gross enrolment ratio (%) of Sao Tome and Principe in 1988?
Give a very brief answer. 63.1. What is the difference between the Gross enrolment ratio (%) in Hungary in 1985 and the Gross enrolment ratio (%) in Sao Tome and Principe in 1988?
Provide a succinct answer. 41.72. What is the difference between the Gross enrolment ratio (%) in East Asia (all income levels) in 1985 and the Gross enrolment ratio (%) in Euro area in 1990?
Offer a very short reply. -66.57. What is the difference between the Gross enrolment ratio (%) of East Asia (all income levels) in 1985 and the Gross enrolment ratio (%) of Hungary in 1990?
Provide a short and direct response. -65.49. What is the difference between the Gross enrolment ratio (%) of East Asia (all income levels) in 1985 and the Gross enrolment ratio (%) of Sao Tome and Principe in 1990?
Your answer should be very brief. -2.12. What is the difference between the Gross enrolment ratio (%) in Euro area in 1985 and the Gross enrolment ratio (%) in Hungary in 1990?
Offer a terse response. 0.92. What is the difference between the Gross enrolment ratio (%) of Euro area in 1985 and the Gross enrolment ratio (%) of Sao Tome and Principe in 1990?
Keep it short and to the point. 64.29. What is the difference between the Gross enrolment ratio (%) in Hungary in 1985 and the Gross enrolment ratio (%) in Sao Tome and Principe in 1990?
Make the answer very short. 42.92. What is the difference between the Gross enrolment ratio (%) in East Asia (all income levels) in 1987 and the Gross enrolment ratio (%) in Euro area in 1988?
Your answer should be compact. -63.03. What is the difference between the Gross enrolment ratio (%) in East Asia (all income levels) in 1987 and the Gross enrolment ratio (%) in Hungary in 1988?
Give a very brief answer. -50.53. What is the difference between the Gross enrolment ratio (%) of East Asia (all income levels) in 1987 and the Gross enrolment ratio (%) of Sao Tome and Principe in 1988?
Keep it short and to the point. -0.22. What is the difference between the Gross enrolment ratio (%) of Euro area in 1987 and the Gross enrolment ratio (%) of Hungary in 1988?
Offer a terse response. 13.46. What is the difference between the Gross enrolment ratio (%) in Euro area in 1987 and the Gross enrolment ratio (%) in Sao Tome and Principe in 1988?
Provide a short and direct response. 63.76. What is the difference between the Gross enrolment ratio (%) in Hungary in 1987 and the Gross enrolment ratio (%) in Sao Tome and Principe in 1988?
Give a very brief answer. 43.96. What is the difference between the Gross enrolment ratio (%) of East Asia (all income levels) in 1987 and the Gross enrolment ratio (%) of Euro area in 1990?
Keep it short and to the point. -63.48. What is the difference between the Gross enrolment ratio (%) of East Asia (all income levels) in 1987 and the Gross enrolment ratio (%) of Hungary in 1990?
Provide a short and direct response. -62.4. What is the difference between the Gross enrolment ratio (%) in East Asia (all income levels) in 1987 and the Gross enrolment ratio (%) in Sao Tome and Principe in 1990?
Make the answer very short. 0.97. What is the difference between the Gross enrolment ratio (%) in Euro area in 1987 and the Gross enrolment ratio (%) in Hungary in 1990?
Your answer should be compact. 1.59. What is the difference between the Gross enrolment ratio (%) in Euro area in 1987 and the Gross enrolment ratio (%) in Sao Tome and Principe in 1990?
Offer a very short reply. 64.96. What is the difference between the Gross enrolment ratio (%) in Hungary in 1987 and the Gross enrolment ratio (%) in Sao Tome and Principe in 1990?
Make the answer very short. 45.15. What is the difference between the Gross enrolment ratio (%) of East Asia (all income levels) in 1988 and the Gross enrolment ratio (%) of Euro area in 1990?
Your response must be concise. -62.37. What is the difference between the Gross enrolment ratio (%) in East Asia (all income levels) in 1988 and the Gross enrolment ratio (%) in Hungary in 1990?
Your answer should be very brief. -61.29. What is the difference between the Gross enrolment ratio (%) in East Asia (all income levels) in 1988 and the Gross enrolment ratio (%) in Sao Tome and Principe in 1990?
Offer a terse response. 2.08. What is the difference between the Gross enrolment ratio (%) in Euro area in 1988 and the Gross enrolment ratio (%) in Hungary in 1990?
Offer a very short reply. 0.64. What is the difference between the Gross enrolment ratio (%) of Euro area in 1988 and the Gross enrolment ratio (%) of Sao Tome and Principe in 1990?
Ensure brevity in your answer.  64.01. What is the difference between the Gross enrolment ratio (%) in Hungary in 1988 and the Gross enrolment ratio (%) in Sao Tome and Principe in 1990?
Your answer should be compact. 51.5. What is the average Gross enrolment ratio (%) of East Asia (all income levels) per year?
Keep it short and to the point. 18.86. What is the average Gross enrolment ratio (%) of Euro area per year?
Give a very brief answer. 83.63. What is the average Gross enrolment ratio (%) of Hungary per year?
Give a very brief answer. 70.49. What is the average Gross enrolment ratio (%) of Sao Tome and Principe per year?
Your answer should be very brief. 21.2. In the year 1981, what is the difference between the Gross enrolment ratio (%) in East Asia (all income levels) and Gross enrolment ratio (%) in Euro area?
Give a very brief answer. -63.53. In the year 1981, what is the difference between the Gross enrolment ratio (%) of East Asia (all income levels) and Gross enrolment ratio (%) of Hungary?
Offer a terse response. -57.83. In the year 1981, what is the difference between the Gross enrolment ratio (%) of East Asia (all income levels) and Gross enrolment ratio (%) of Sao Tome and Principe?
Provide a short and direct response. -4.41. In the year 1981, what is the difference between the Gross enrolment ratio (%) in Euro area and Gross enrolment ratio (%) in Hungary?
Ensure brevity in your answer.  5.7. In the year 1981, what is the difference between the Gross enrolment ratio (%) of Euro area and Gross enrolment ratio (%) of Sao Tome and Principe?
Provide a short and direct response. 59.12. In the year 1981, what is the difference between the Gross enrolment ratio (%) of Hungary and Gross enrolment ratio (%) of Sao Tome and Principe?
Provide a succinct answer. 53.42. In the year 1982, what is the difference between the Gross enrolment ratio (%) of East Asia (all income levels) and Gross enrolment ratio (%) of Euro area?
Make the answer very short. -65.16. In the year 1982, what is the difference between the Gross enrolment ratio (%) in East Asia (all income levels) and Gross enrolment ratio (%) in Hungary?
Make the answer very short. -55.61. In the year 1982, what is the difference between the Gross enrolment ratio (%) of East Asia (all income levels) and Gross enrolment ratio (%) of Sao Tome and Principe?
Your answer should be compact. -5.26. In the year 1982, what is the difference between the Gross enrolment ratio (%) in Euro area and Gross enrolment ratio (%) in Hungary?
Keep it short and to the point. 9.55. In the year 1982, what is the difference between the Gross enrolment ratio (%) of Euro area and Gross enrolment ratio (%) of Sao Tome and Principe?
Offer a very short reply. 59.9. In the year 1982, what is the difference between the Gross enrolment ratio (%) of Hungary and Gross enrolment ratio (%) of Sao Tome and Principe?
Offer a terse response. 50.35. In the year 1983, what is the difference between the Gross enrolment ratio (%) of East Asia (all income levels) and Gross enrolment ratio (%) of Euro area?
Make the answer very short. -66.22. In the year 1983, what is the difference between the Gross enrolment ratio (%) in East Asia (all income levels) and Gross enrolment ratio (%) in Hungary?
Offer a very short reply. -51.06. In the year 1983, what is the difference between the Gross enrolment ratio (%) in East Asia (all income levels) and Gross enrolment ratio (%) in Sao Tome and Principe?
Offer a very short reply. -4.6. In the year 1983, what is the difference between the Gross enrolment ratio (%) in Euro area and Gross enrolment ratio (%) in Hungary?
Ensure brevity in your answer.  15.16. In the year 1983, what is the difference between the Gross enrolment ratio (%) in Euro area and Gross enrolment ratio (%) in Sao Tome and Principe?
Give a very brief answer. 61.62. In the year 1983, what is the difference between the Gross enrolment ratio (%) of Hungary and Gross enrolment ratio (%) of Sao Tome and Principe?
Give a very brief answer. 46.46. In the year 1984, what is the difference between the Gross enrolment ratio (%) in East Asia (all income levels) and Gross enrolment ratio (%) in Euro area?
Give a very brief answer. -67.19. In the year 1984, what is the difference between the Gross enrolment ratio (%) of East Asia (all income levels) and Gross enrolment ratio (%) of Hungary?
Keep it short and to the point. -47.24. In the year 1984, what is the difference between the Gross enrolment ratio (%) in East Asia (all income levels) and Gross enrolment ratio (%) in Sao Tome and Principe?
Make the answer very short. -3.87. In the year 1984, what is the difference between the Gross enrolment ratio (%) in Euro area and Gross enrolment ratio (%) in Hungary?
Provide a succinct answer. 19.95. In the year 1984, what is the difference between the Gross enrolment ratio (%) in Euro area and Gross enrolment ratio (%) in Sao Tome and Principe?
Your answer should be very brief. 63.33. In the year 1984, what is the difference between the Gross enrolment ratio (%) in Hungary and Gross enrolment ratio (%) in Sao Tome and Principe?
Your response must be concise. 43.37. In the year 1985, what is the difference between the Gross enrolment ratio (%) of East Asia (all income levels) and Gross enrolment ratio (%) of Euro area?
Provide a short and direct response. -66.42. In the year 1985, what is the difference between the Gross enrolment ratio (%) of East Asia (all income levels) and Gross enrolment ratio (%) of Hungary?
Ensure brevity in your answer.  -45.04. In the year 1985, what is the difference between the Gross enrolment ratio (%) of East Asia (all income levels) and Gross enrolment ratio (%) of Sao Tome and Principe?
Make the answer very short. -2.31. In the year 1985, what is the difference between the Gross enrolment ratio (%) of Euro area and Gross enrolment ratio (%) of Hungary?
Your answer should be very brief. 21.37. In the year 1985, what is the difference between the Gross enrolment ratio (%) of Euro area and Gross enrolment ratio (%) of Sao Tome and Principe?
Your response must be concise. 64.11. In the year 1985, what is the difference between the Gross enrolment ratio (%) of Hungary and Gross enrolment ratio (%) of Sao Tome and Principe?
Make the answer very short. 42.73. In the year 1987, what is the difference between the Gross enrolment ratio (%) of East Asia (all income levels) and Gross enrolment ratio (%) of Euro area?
Provide a succinct answer. -63.99. In the year 1987, what is the difference between the Gross enrolment ratio (%) of East Asia (all income levels) and Gross enrolment ratio (%) of Hungary?
Ensure brevity in your answer.  -44.18. In the year 1987, what is the difference between the Gross enrolment ratio (%) in East Asia (all income levels) and Gross enrolment ratio (%) in Sao Tome and Principe?
Offer a very short reply. 0.14. In the year 1987, what is the difference between the Gross enrolment ratio (%) of Euro area and Gross enrolment ratio (%) of Hungary?
Provide a short and direct response. 19.81. In the year 1987, what is the difference between the Gross enrolment ratio (%) in Euro area and Gross enrolment ratio (%) in Sao Tome and Principe?
Your response must be concise. 64.12. In the year 1987, what is the difference between the Gross enrolment ratio (%) of Hungary and Gross enrolment ratio (%) of Sao Tome and Principe?
Ensure brevity in your answer.  44.32. In the year 1988, what is the difference between the Gross enrolment ratio (%) of East Asia (all income levels) and Gross enrolment ratio (%) of Euro area?
Keep it short and to the point. -61.93. In the year 1988, what is the difference between the Gross enrolment ratio (%) of East Asia (all income levels) and Gross enrolment ratio (%) of Hungary?
Ensure brevity in your answer.  -49.43. In the year 1988, what is the difference between the Gross enrolment ratio (%) of East Asia (all income levels) and Gross enrolment ratio (%) of Sao Tome and Principe?
Give a very brief answer. 0.88. In the year 1988, what is the difference between the Gross enrolment ratio (%) of Euro area and Gross enrolment ratio (%) of Hungary?
Give a very brief answer. 12.5. In the year 1988, what is the difference between the Gross enrolment ratio (%) of Euro area and Gross enrolment ratio (%) of Sao Tome and Principe?
Provide a short and direct response. 62.81. In the year 1988, what is the difference between the Gross enrolment ratio (%) of Hungary and Gross enrolment ratio (%) of Sao Tome and Principe?
Provide a succinct answer. 50.31. In the year 1990, what is the difference between the Gross enrolment ratio (%) of East Asia (all income levels) and Gross enrolment ratio (%) of Euro area?
Keep it short and to the point. -63.75. In the year 1990, what is the difference between the Gross enrolment ratio (%) in East Asia (all income levels) and Gross enrolment ratio (%) in Hungary?
Your answer should be very brief. -62.67. In the year 1990, what is the difference between the Gross enrolment ratio (%) of East Asia (all income levels) and Gross enrolment ratio (%) of Sao Tome and Principe?
Provide a short and direct response. 0.7. In the year 1990, what is the difference between the Gross enrolment ratio (%) in Euro area and Gross enrolment ratio (%) in Hungary?
Ensure brevity in your answer.  1.08. In the year 1990, what is the difference between the Gross enrolment ratio (%) in Euro area and Gross enrolment ratio (%) in Sao Tome and Principe?
Provide a succinct answer. 64.45. In the year 1990, what is the difference between the Gross enrolment ratio (%) of Hungary and Gross enrolment ratio (%) of Sao Tome and Principe?
Your answer should be compact. 63.37. What is the ratio of the Gross enrolment ratio (%) of East Asia (all income levels) in 1981 to that in 1982?
Provide a short and direct response. 1. What is the ratio of the Gross enrolment ratio (%) of Euro area in 1981 to that in 1982?
Ensure brevity in your answer.  0.98. What is the ratio of the Gross enrolment ratio (%) in Hungary in 1981 to that in 1982?
Make the answer very short. 1.03. What is the ratio of the Gross enrolment ratio (%) in Sao Tome and Principe in 1981 to that in 1982?
Offer a terse response. 0.96. What is the ratio of the Gross enrolment ratio (%) of East Asia (all income levels) in 1981 to that in 1983?
Give a very brief answer. 0.93. What is the ratio of the Gross enrolment ratio (%) in Euro area in 1981 to that in 1983?
Provide a succinct answer. 0.95. What is the ratio of the Gross enrolment ratio (%) in Hungary in 1981 to that in 1983?
Give a very brief answer. 1.08. What is the ratio of the Gross enrolment ratio (%) of Sao Tome and Principe in 1981 to that in 1983?
Provide a short and direct response. 0.93. What is the ratio of the Gross enrolment ratio (%) of East Asia (all income levels) in 1981 to that in 1984?
Give a very brief answer. 0.86. What is the ratio of the Gross enrolment ratio (%) of Euro area in 1981 to that in 1984?
Offer a very short reply. 0.93. What is the ratio of the Gross enrolment ratio (%) in Hungary in 1981 to that in 1984?
Give a very brief answer. 1.13. What is the ratio of the Gross enrolment ratio (%) in Sao Tome and Principe in 1981 to that in 1984?
Give a very brief answer. 0.91. What is the ratio of the Gross enrolment ratio (%) in East Asia (all income levels) in 1981 to that in 1985?
Offer a very short reply. 0.77. What is the ratio of the Gross enrolment ratio (%) of Euro area in 1981 to that in 1985?
Offer a terse response. 0.92. What is the ratio of the Gross enrolment ratio (%) in Hungary in 1981 to that in 1985?
Your answer should be very brief. 1.13. What is the ratio of the Gross enrolment ratio (%) of Sao Tome and Principe in 1981 to that in 1985?
Your response must be concise. 0.9. What is the ratio of the Gross enrolment ratio (%) in East Asia (all income levels) in 1981 to that in 1987?
Provide a short and direct response. 0.67. What is the ratio of the Gross enrolment ratio (%) of Euro area in 1981 to that in 1987?
Provide a short and direct response. 0.91. What is the ratio of the Gross enrolment ratio (%) of Hungary in 1981 to that in 1987?
Provide a succinct answer. 1.09. What is the ratio of the Gross enrolment ratio (%) in Sao Tome and Principe in 1981 to that in 1987?
Your answer should be compact. 0.87. What is the ratio of the Gross enrolment ratio (%) of East Asia (all income levels) in 1981 to that in 1988?
Keep it short and to the point. 0.64. What is the ratio of the Gross enrolment ratio (%) of Euro area in 1981 to that in 1988?
Offer a terse response. 0.92. What is the ratio of the Gross enrolment ratio (%) in Hungary in 1981 to that in 1988?
Provide a succinct answer. 1. What is the ratio of the Gross enrolment ratio (%) in Sao Tome and Principe in 1981 to that in 1988?
Offer a terse response. 0.86. What is the ratio of the Gross enrolment ratio (%) of East Asia (all income levels) in 1981 to that in 1990?
Provide a succinct answer. 0.68. What is the ratio of the Gross enrolment ratio (%) in Euro area in 1981 to that in 1990?
Provide a succinct answer. 0.91. What is the ratio of the Gross enrolment ratio (%) of Hungary in 1981 to that in 1990?
Your response must be concise. 0.86. What is the ratio of the Gross enrolment ratio (%) of Sao Tome and Principe in 1981 to that in 1990?
Provide a succinct answer. 0.9. What is the ratio of the Gross enrolment ratio (%) of East Asia (all income levels) in 1982 to that in 1983?
Give a very brief answer. 0.93. What is the ratio of the Gross enrolment ratio (%) in Euro area in 1982 to that in 1983?
Provide a succinct answer. 0.97. What is the ratio of the Gross enrolment ratio (%) in Hungary in 1982 to that in 1983?
Offer a very short reply. 1.05. What is the ratio of the Gross enrolment ratio (%) of Sao Tome and Principe in 1982 to that in 1983?
Provide a short and direct response. 0.98. What is the ratio of the Gross enrolment ratio (%) in East Asia (all income levels) in 1982 to that in 1984?
Offer a terse response. 0.86. What is the ratio of the Gross enrolment ratio (%) in Euro area in 1982 to that in 1984?
Your answer should be compact. 0.95. What is the ratio of the Gross enrolment ratio (%) in Hungary in 1982 to that in 1984?
Keep it short and to the point. 1.09. What is the ratio of the Gross enrolment ratio (%) in Sao Tome and Principe in 1982 to that in 1984?
Your answer should be very brief. 0.95. What is the ratio of the Gross enrolment ratio (%) in East Asia (all income levels) in 1982 to that in 1985?
Make the answer very short. 0.78. What is the ratio of the Gross enrolment ratio (%) of Euro area in 1982 to that in 1985?
Your answer should be compact. 0.94. What is the ratio of the Gross enrolment ratio (%) of Hungary in 1982 to that in 1985?
Provide a succinct answer. 1.1. What is the ratio of the Gross enrolment ratio (%) in Sao Tome and Principe in 1982 to that in 1985?
Ensure brevity in your answer.  0.94. What is the ratio of the Gross enrolment ratio (%) in East Asia (all income levels) in 1982 to that in 1987?
Provide a succinct answer. 0.67. What is the ratio of the Gross enrolment ratio (%) of Euro area in 1982 to that in 1987?
Your answer should be very brief. 0.93. What is the ratio of the Gross enrolment ratio (%) in Hungary in 1982 to that in 1987?
Provide a succinct answer. 1.06. What is the ratio of the Gross enrolment ratio (%) in Sao Tome and Principe in 1982 to that in 1987?
Provide a succinct answer. 0.91. What is the ratio of the Gross enrolment ratio (%) in East Asia (all income levels) in 1982 to that in 1988?
Keep it short and to the point. 0.64. What is the ratio of the Gross enrolment ratio (%) of Euro area in 1982 to that in 1988?
Ensure brevity in your answer.  0.94. What is the ratio of the Gross enrolment ratio (%) of Hungary in 1982 to that in 1988?
Provide a succinct answer. 0.97. What is the ratio of the Gross enrolment ratio (%) of Sao Tome and Principe in 1982 to that in 1988?
Offer a very short reply. 0.89. What is the ratio of the Gross enrolment ratio (%) in East Asia (all income levels) in 1982 to that in 1990?
Offer a terse response. 0.68. What is the ratio of the Gross enrolment ratio (%) in Hungary in 1982 to that in 1990?
Ensure brevity in your answer.  0.83. What is the ratio of the Gross enrolment ratio (%) of Sao Tome and Principe in 1982 to that in 1990?
Your response must be concise. 0.94. What is the ratio of the Gross enrolment ratio (%) of East Asia (all income levels) in 1983 to that in 1984?
Give a very brief answer. 0.93. What is the ratio of the Gross enrolment ratio (%) of Euro area in 1983 to that in 1984?
Provide a succinct answer. 0.97. What is the ratio of the Gross enrolment ratio (%) of Hungary in 1983 to that in 1984?
Provide a short and direct response. 1.04. What is the ratio of the Gross enrolment ratio (%) of Sao Tome and Principe in 1983 to that in 1984?
Your answer should be compact. 0.97. What is the ratio of the Gross enrolment ratio (%) in East Asia (all income levels) in 1983 to that in 1985?
Ensure brevity in your answer.  0.84. What is the ratio of the Gross enrolment ratio (%) in Euro area in 1983 to that in 1985?
Provide a succinct answer. 0.96. What is the ratio of the Gross enrolment ratio (%) in Hungary in 1983 to that in 1985?
Your answer should be compact. 1.04. What is the ratio of the Gross enrolment ratio (%) in Sao Tome and Principe in 1983 to that in 1985?
Make the answer very short. 0.96. What is the ratio of the Gross enrolment ratio (%) of East Asia (all income levels) in 1983 to that in 1987?
Your answer should be very brief. 0.72. What is the ratio of the Gross enrolment ratio (%) of Euro area in 1983 to that in 1987?
Provide a succinct answer. 0.95. What is the ratio of the Gross enrolment ratio (%) in Hungary in 1983 to that in 1987?
Provide a succinct answer. 1.01. What is the ratio of the Gross enrolment ratio (%) in Sao Tome and Principe in 1983 to that in 1987?
Provide a succinct answer. 0.93. What is the ratio of the Gross enrolment ratio (%) in East Asia (all income levels) in 1983 to that in 1988?
Offer a terse response. 0.69. What is the ratio of the Gross enrolment ratio (%) in Euro area in 1983 to that in 1988?
Provide a succinct answer. 0.96. What is the ratio of the Gross enrolment ratio (%) of Hungary in 1983 to that in 1988?
Keep it short and to the point. 0.92. What is the ratio of the Gross enrolment ratio (%) of Sao Tome and Principe in 1983 to that in 1988?
Ensure brevity in your answer.  0.92. What is the ratio of the Gross enrolment ratio (%) of East Asia (all income levels) in 1983 to that in 1990?
Your answer should be very brief. 0.73. What is the ratio of the Gross enrolment ratio (%) in Euro area in 1983 to that in 1990?
Your answer should be compact. 0.96. What is the ratio of the Gross enrolment ratio (%) in Hungary in 1983 to that in 1990?
Make the answer very short. 0.79. What is the ratio of the Gross enrolment ratio (%) of Sao Tome and Principe in 1983 to that in 1990?
Provide a succinct answer. 0.97. What is the ratio of the Gross enrolment ratio (%) of East Asia (all income levels) in 1984 to that in 1985?
Provide a short and direct response. 0.9. What is the ratio of the Gross enrolment ratio (%) in Euro area in 1984 to that in 1985?
Give a very brief answer. 0.99. What is the ratio of the Gross enrolment ratio (%) of Hungary in 1984 to that in 1985?
Your response must be concise. 1. What is the ratio of the Gross enrolment ratio (%) of East Asia (all income levels) in 1984 to that in 1987?
Offer a very short reply. 0.78. What is the ratio of the Gross enrolment ratio (%) in Euro area in 1984 to that in 1987?
Provide a succinct answer. 0.98. What is the ratio of the Gross enrolment ratio (%) in Hungary in 1984 to that in 1987?
Offer a very short reply. 0.97. What is the ratio of the Gross enrolment ratio (%) in Sao Tome and Principe in 1984 to that in 1987?
Offer a very short reply. 0.96. What is the ratio of the Gross enrolment ratio (%) of East Asia (all income levels) in 1984 to that in 1988?
Offer a very short reply. 0.74. What is the ratio of the Gross enrolment ratio (%) of Hungary in 1984 to that in 1988?
Ensure brevity in your answer.  0.89. What is the ratio of the Gross enrolment ratio (%) of Sao Tome and Principe in 1984 to that in 1988?
Your response must be concise. 0.94. What is the ratio of the Gross enrolment ratio (%) of East Asia (all income levels) in 1984 to that in 1990?
Make the answer very short. 0.79. What is the ratio of the Gross enrolment ratio (%) in Euro area in 1984 to that in 1990?
Your response must be concise. 0.99. What is the ratio of the Gross enrolment ratio (%) of Hungary in 1984 to that in 1990?
Offer a terse response. 0.76. What is the ratio of the Gross enrolment ratio (%) in Sao Tome and Principe in 1984 to that in 1990?
Your response must be concise. 0.99. What is the ratio of the Gross enrolment ratio (%) in East Asia (all income levels) in 1985 to that in 1987?
Your answer should be compact. 0.86. What is the ratio of the Gross enrolment ratio (%) in Hungary in 1985 to that in 1987?
Your answer should be very brief. 0.97. What is the ratio of the Gross enrolment ratio (%) of Sao Tome and Principe in 1985 to that in 1987?
Provide a short and direct response. 0.97. What is the ratio of the Gross enrolment ratio (%) in East Asia (all income levels) in 1985 to that in 1988?
Make the answer very short. 0.82. What is the ratio of the Gross enrolment ratio (%) in Euro area in 1985 to that in 1988?
Provide a short and direct response. 1. What is the ratio of the Gross enrolment ratio (%) of Hungary in 1985 to that in 1988?
Your answer should be very brief. 0.88. What is the ratio of the Gross enrolment ratio (%) in Sao Tome and Principe in 1985 to that in 1988?
Keep it short and to the point. 0.96. What is the ratio of the Gross enrolment ratio (%) in East Asia (all income levels) in 1985 to that in 1990?
Your answer should be very brief. 0.87. What is the ratio of the Gross enrolment ratio (%) in Euro area in 1985 to that in 1990?
Your answer should be very brief. 1. What is the ratio of the Gross enrolment ratio (%) of Hungary in 1985 to that in 1990?
Provide a succinct answer. 0.76. What is the ratio of the Gross enrolment ratio (%) of Sao Tome and Principe in 1985 to that in 1990?
Give a very brief answer. 1.01. What is the ratio of the Gross enrolment ratio (%) in East Asia (all income levels) in 1987 to that in 1988?
Offer a terse response. 0.95. What is the ratio of the Gross enrolment ratio (%) in Euro area in 1987 to that in 1988?
Your response must be concise. 1.01. What is the ratio of the Gross enrolment ratio (%) of Hungary in 1987 to that in 1988?
Provide a short and direct response. 0.91. What is the ratio of the Gross enrolment ratio (%) in Sao Tome and Principe in 1987 to that in 1988?
Your response must be concise. 0.98. What is the ratio of the Gross enrolment ratio (%) of East Asia (all income levels) in 1987 to that in 1990?
Your answer should be very brief. 1.01. What is the ratio of the Gross enrolment ratio (%) of Euro area in 1987 to that in 1990?
Your answer should be very brief. 1.01. What is the ratio of the Gross enrolment ratio (%) of Hungary in 1987 to that in 1990?
Ensure brevity in your answer.  0.79. What is the ratio of the Gross enrolment ratio (%) in Sao Tome and Principe in 1987 to that in 1990?
Give a very brief answer. 1.04. What is the ratio of the Gross enrolment ratio (%) of East Asia (all income levels) in 1988 to that in 1990?
Give a very brief answer. 1.06. What is the ratio of the Gross enrolment ratio (%) of Hungary in 1988 to that in 1990?
Keep it short and to the point. 0.86. What is the ratio of the Gross enrolment ratio (%) in Sao Tome and Principe in 1988 to that in 1990?
Provide a succinct answer. 1.06. What is the difference between the highest and the second highest Gross enrolment ratio (%) in East Asia (all income levels)?
Provide a succinct answer. 1.1. What is the difference between the highest and the second highest Gross enrolment ratio (%) in Euro area?
Your answer should be compact. 0.51. What is the difference between the highest and the second highest Gross enrolment ratio (%) in Hungary?
Your response must be concise. 11.87. What is the difference between the highest and the second highest Gross enrolment ratio (%) of Sao Tome and Principe?
Provide a succinct answer. 0.36. What is the difference between the highest and the lowest Gross enrolment ratio (%) in East Asia (all income levels)?
Provide a succinct answer. 8.55. What is the difference between the highest and the lowest Gross enrolment ratio (%) of Euro area?
Ensure brevity in your answer.  7.9. What is the difference between the highest and the lowest Gross enrolment ratio (%) in Hungary?
Your answer should be very brief. 20.45. What is the difference between the highest and the lowest Gross enrolment ratio (%) of Sao Tome and Principe?
Your answer should be compact. 3.26. 